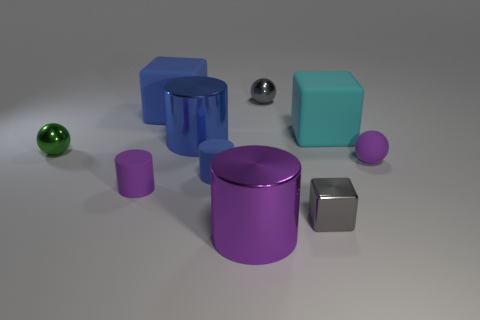Subtract all small gray metallic cubes. How many cubes are left? 2 Subtract 2 cylinders. How many cylinders are left? 2 Subtract all brown balls. How many blue cylinders are left? 2 Subtract all spheres. How many objects are left? 7 Add 5 purple cylinders. How many purple cylinders are left? 7 Add 4 large blue shiny objects. How many large blue shiny objects exist? 5 Subtract 0 green cylinders. How many objects are left? 10 Subtract all brown blocks. Subtract all gray cylinders. How many blocks are left? 3 Subtract all tiny red metal balls. Subtract all large metallic things. How many objects are left? 8 